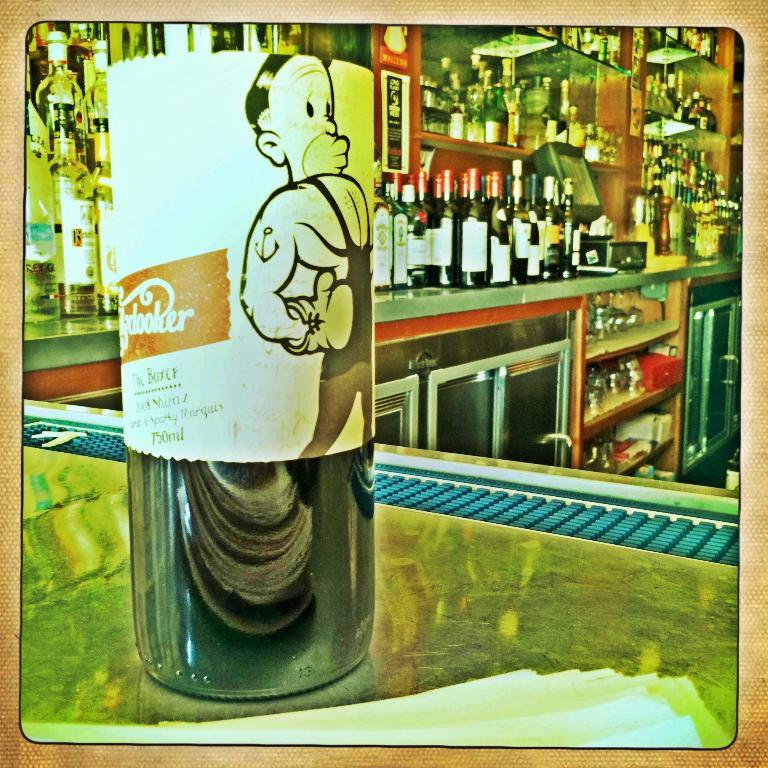What is the main object on the surface in the image? There is an object on the surface in the image, but the specific details are not provided. What type of items are grouped together in the image? There is a group of bottles in the image. Where are additional objects located in the image? There are objects on shelves in the image. What type of fuel is being used by the object on the surface in the image? There is no information about fuel or any object using fuel in the image. 